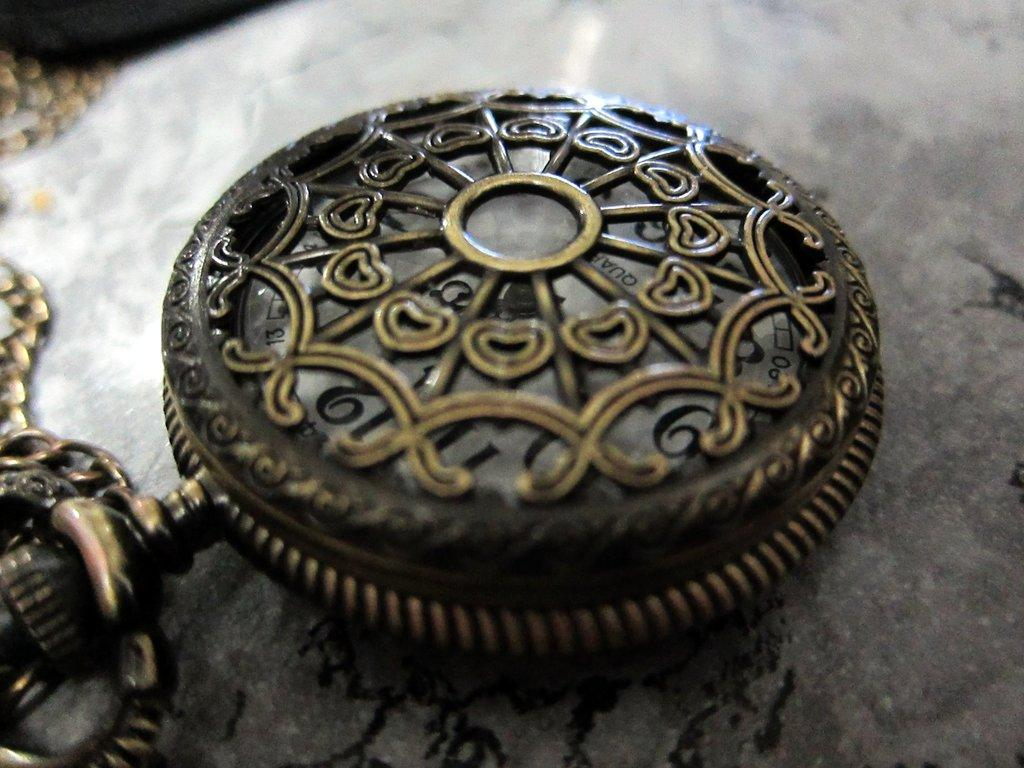What type of material is the object in the image made of? The object in the image is made of metal. Can you describe the surface on which the metal object is placed? The metal object is on a grey surface. How many ice cubes are present in the image? There is no ice or ice cubes present in the image. Can you tell me how many parents are visible in the image? There is no parent or person visible in the image. Are there any giants present in the image? There is no giant or any indication of a giant in the image. 